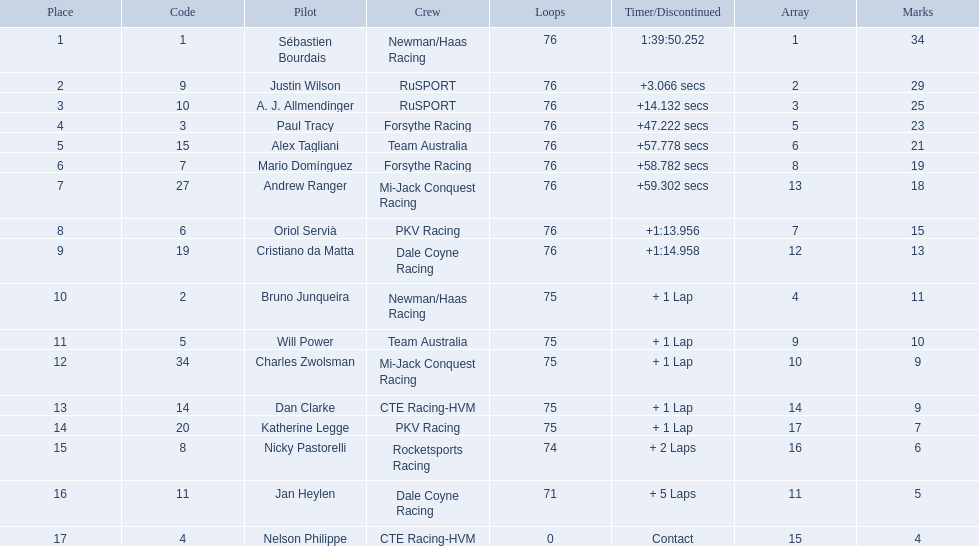Which drivers completed all 76 laps? Sébastien Bourdais, Justin Wilson, A. J. Allmendinger, Paul Tracy, Alex Tagliani, Mario Domínguez, Andrew Ranger, Oriol Servià, Cristiano da Matta. Of these drivers, which ones finished less than a minute behind first place? Paul Tracy, Alex Tagliani, Mario Domínguez, Andrew Ranger. Of these drivers, which ones finished with a time less than 50 seconds behind first place? Justin Wilson, A. J. Allmendinger, Paul Tracy. Of these three drivers, who finished last? Paul Tracy. 